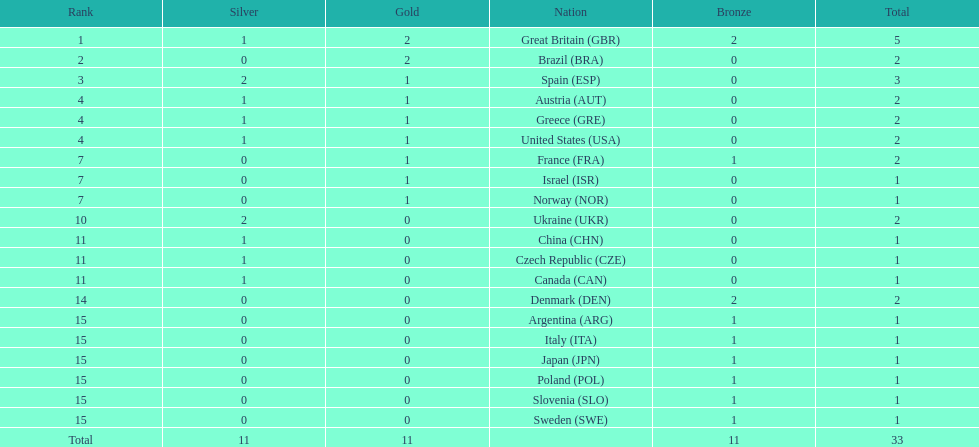How many gold medals did italy receive? 0. 